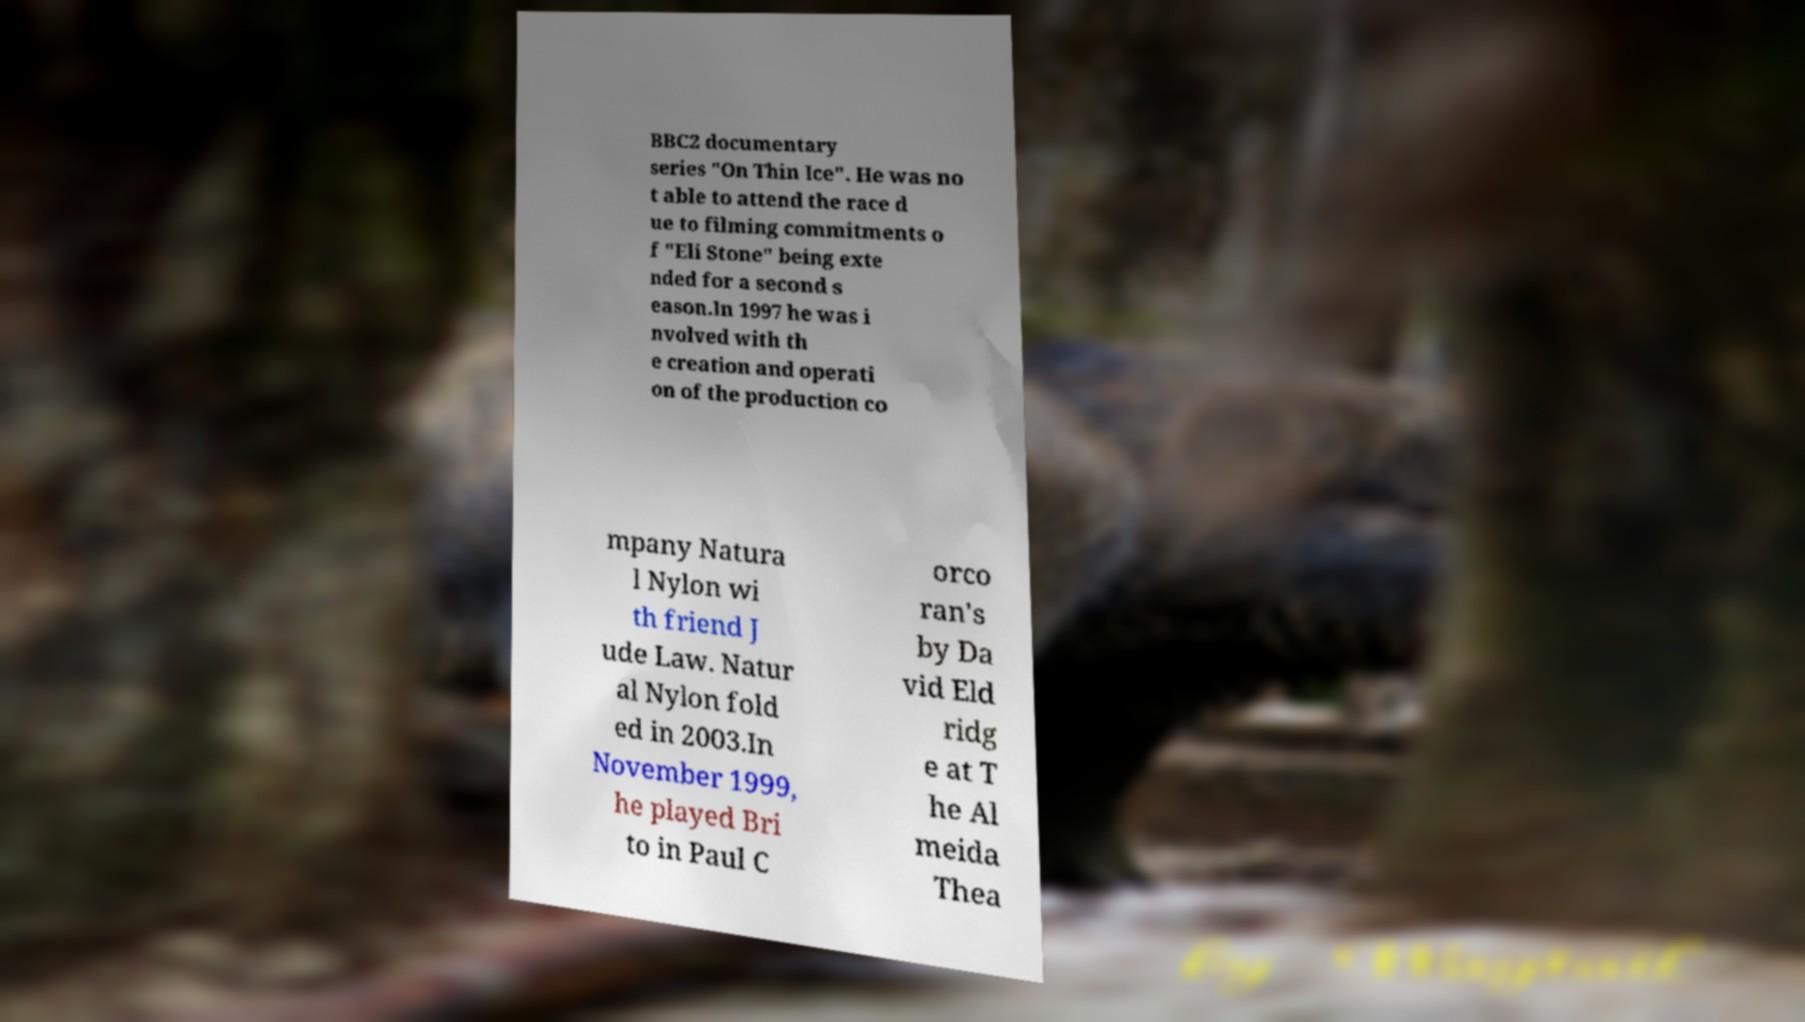Please identify and transcribe the text found in this image. BBC2 documentary series "On Thin Ice". He was no t able to attend the race d ue to filming commitments o f "Eli Stone" being exte nded for a second s eason.In 1997 he was i nvolved with th e creation and operati on of the production co mpany Natura l Nylon wi th friend J ude Law. Natur al Nylon fold ed in 2003.In November 1999, he played Bri to in Paul C orco ran's by Da vid Eld ridg e at T he Al meida Thea 